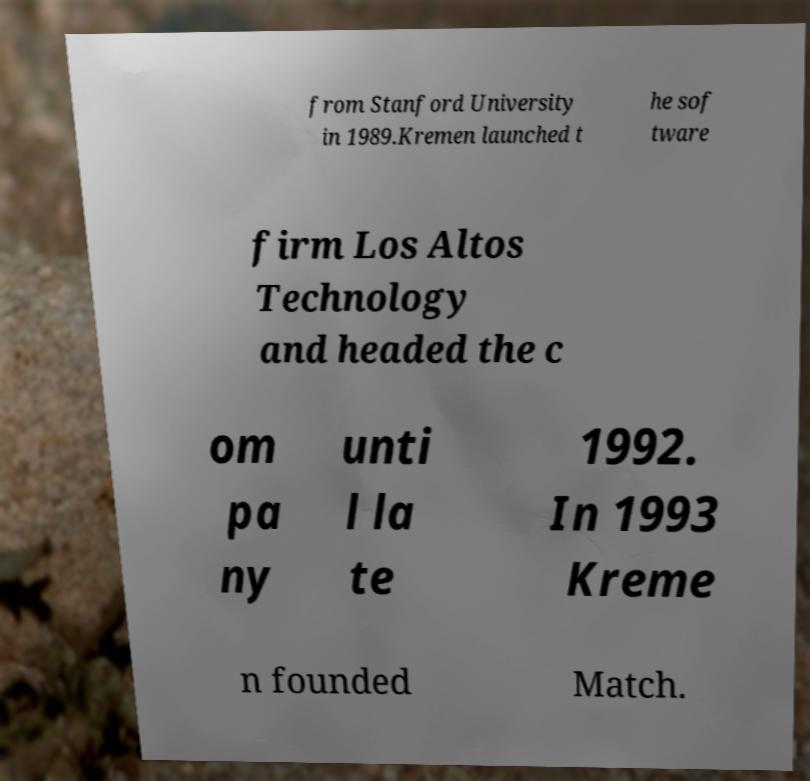What messages or text are displayed in this image? I need them in a readable, typed format. from Stanford University in 1989.Kremen launched t he sof tware firm Los Altos Technology and headed the c om pa ny unti l la te 1992. In 1993 Kreme n founded Match. 